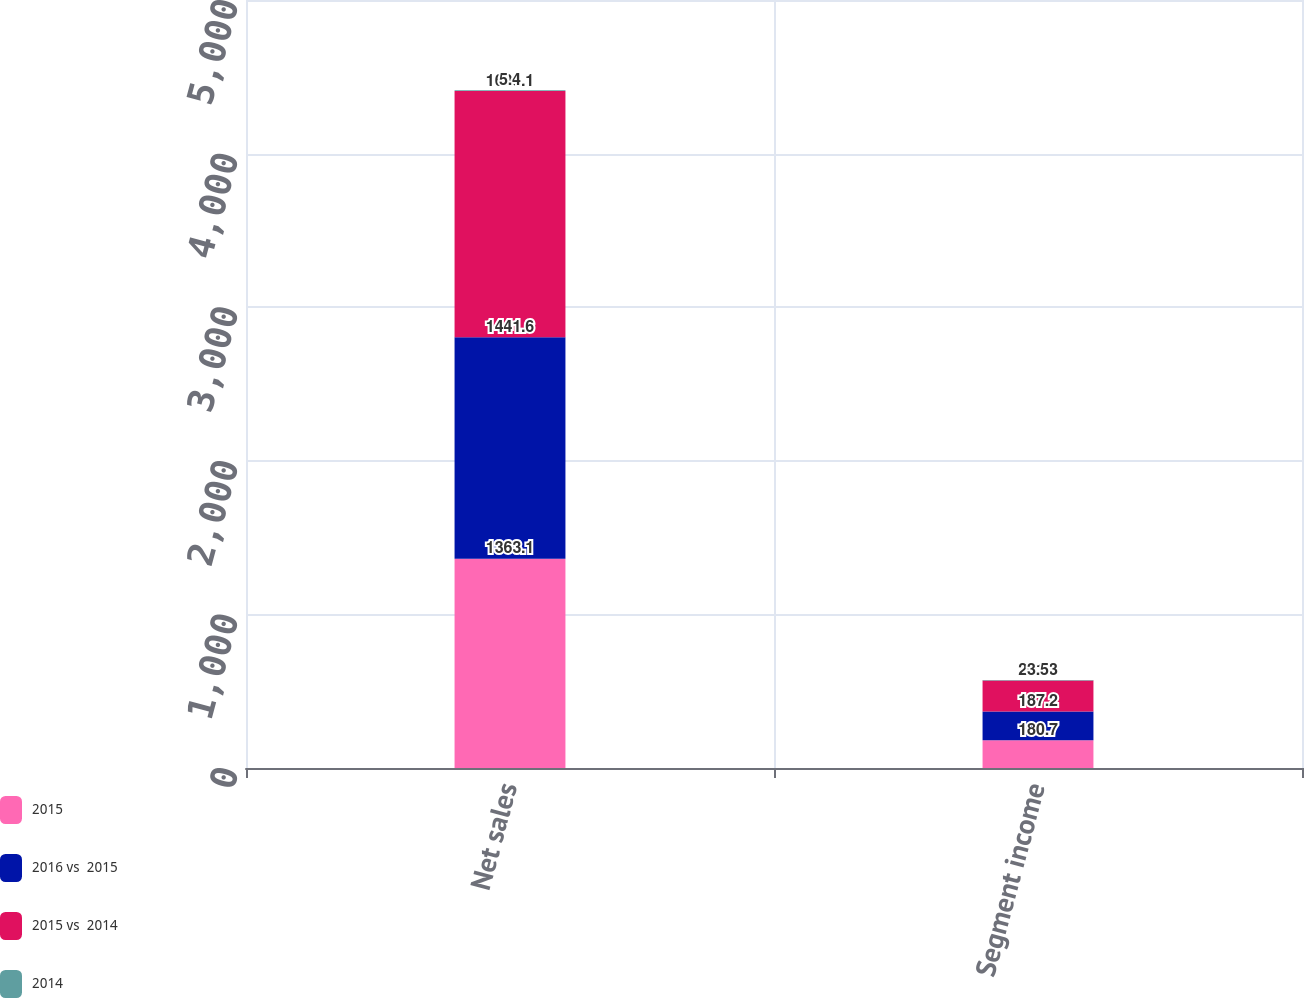Convert chart. <chart><loc_0><loc_0><loc_500><loc_500><stacked_bar_chart><ecel><fcel>Net sales<fcel>Segment income<nl><fcel>2015<fcel>1363.1<fcel>180.7<nl><fcel>2016 vs  2015<fcel>1441.6<fcel>187.2<nl><fcel>2015 vs  2014<fcel>1603.1<fcel>201.3<nl><fcel>2014<fcel>5.4<fcel>3.5<nl></chart> 